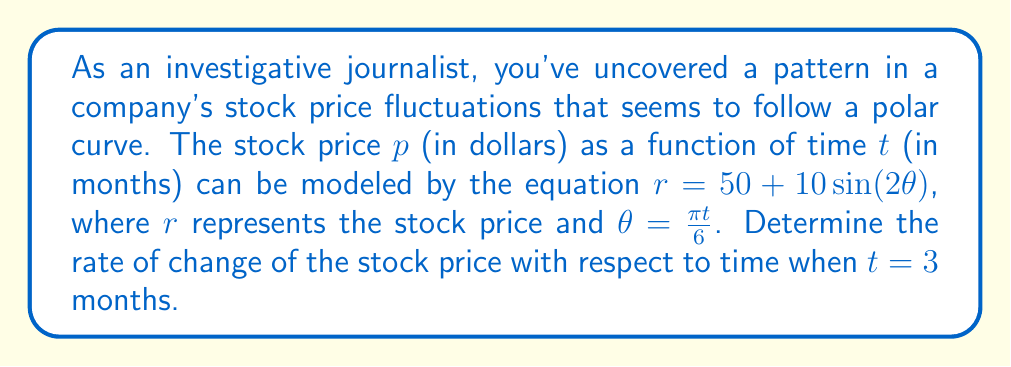Can you answer this question? To solve this problem, we need to use polar derivatives and the chain rule. Let's break it down step-by-step:

1) First, we need to express $r$ in terms of $t$:
   $r = 50 + 10\sin(2\theta) = 50 + 10\sin(2 \cdot \frac{\pi t}{6}) = 50 + 10\sin(\frac{\pi t}{3})$

2) Now, we need to find $\frac{dr}{dt}$. We can use the chain rule:
   $$\frac{dr}{dt} = \frac{dr}{d\theta} \cdot \frac{d\theta}{dt}$$

3) Let's find $\frac{dr}{d\theta}$:
   $$\frac{dr}{d\theta} = 20\cos(2\theta)$$

4) Now, $\frac{d\theta}{dt}$:
   $$\frac{d\theta}{dt} = \frac{\pi}{6}$$

5) Substituting these back into the chain rule equation:
   $$\frac{dr}{dt} = 20\cos(2\theta) \cdot \frac{\pi}{6} = \frac{10\pi}{3}\cos(2\theta)$$

6) At $t = 3$ months, $\theta = \frac{\pi t}{6} = \frac{\pi}{2}$

7) Substituting this value:
   $$\frac{dr}{dt}\bigg|_{t=3} = \frac{10\pi}{3}\cos(2 \cdot \frac{\pi}{2}) = \frac{10\pi}{3}\cos(\pi) = -\frac{10\pi}{3}$$

Therefore, the rate of change of the stock price at $t = 3$ months is $-\frac{10\pi}{3}$ dollars per month.
Answer: $-\frac{10\pi}{3}$ dollars per month 